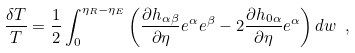<formula> <loc_0><loc_0><loc_500><loc_500>\frac { \delta T } { T } = \frac { 1 } { 2 } \int _ { 0 } ^ { \eta _ { R } - \eta _ { E } } \left ( \frac { \partial h _ { \alpha \beta } } { \partial \eta } e ^ { \alpha } e ^ { \beta } - 2 \frac { \partial h _ { 0 \alpha } } { \partial \eta } e ^ { \alpha } \right ) d w \ ,</formula> 